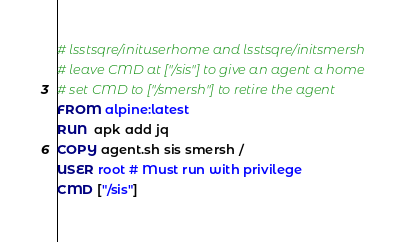<code> <loc_0><loc_0><loc_500><loc_500><_Dockerfile_># lsstsqre/inituserhome and lsstsqre/initsmersh
# leave CMD at ["/sis"] to give an agent a home
# set CMD to ["/smersh"] to retire the agent
FROM alpine:latest
RUN  apk add jq
COPY agent.sh sis smersh /
USER root # Must run with privilege
CMD ["/sis"]
</code> 